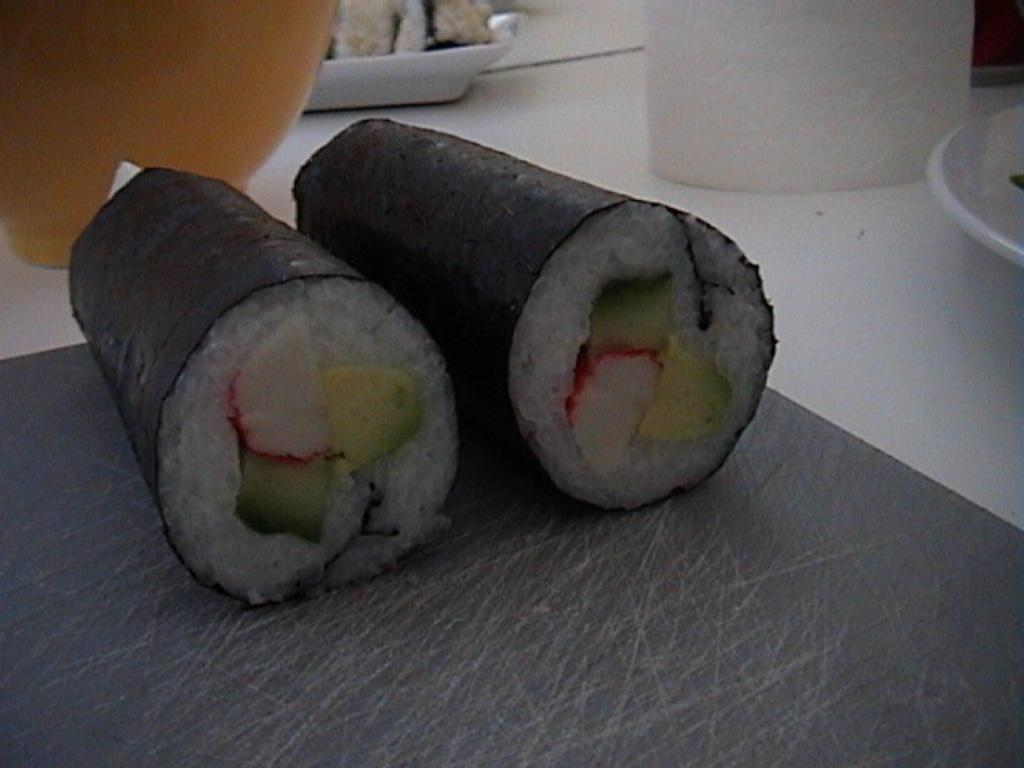What is the color scheme of the food in the image? The food in the image is black and white in color. What objects are used to serve the food in the image? There are plates visible in the image. Can you describe any other items present in the image besides the food and plates? There are other unspecified items in the image. How does the feeling of the paper affect the organization of the image? There is no paper present in the image, and therefore the feeling of paper cannot affect the organization of the image. 